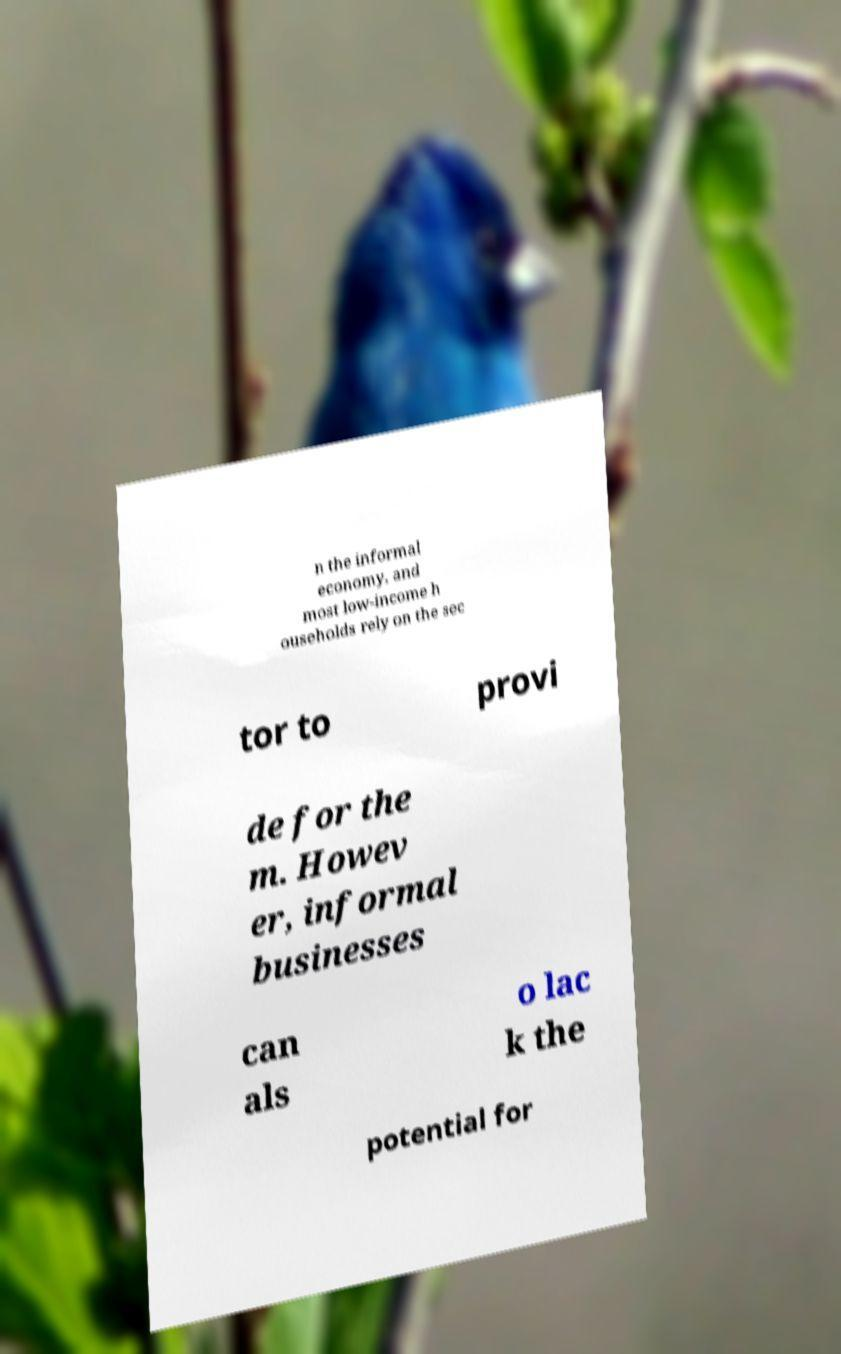Can you accurately transcribe the text from the provided image for me? n the informal economy, and most low-income h ouseholds rely on the sec tor to provi de for the m. Howev er, informal businesses can als o lac k the potential for 